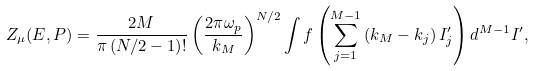Convert formula to latex. <formula><loc_0><loc_0><loc_500><loc_500>Z _ { \mu } ( E , P ) = \frac { 2 M } { \pi \left ( N / 2 - 1 \right ) ! } \left ( \frac { 2 \pi \omega _ { p } } { k _ { M } } \right ) ^ { N / 2 } \int f \left ( \sum _ { j = 1 } ^ { M - 1 } \left ( k _ { M } - k _ { j } \right ) I _ { j } ^ { \prime } \right ) d ^ { M - 1 } I ^ { \prime } ,</formula> 